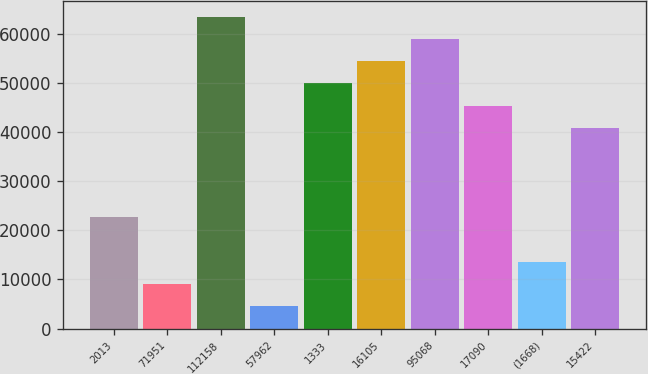Convert chart. <chart><loc_0><loc_0><loc_500><loc_500><bar_chart><fcel>2013<fcel>71951<fcel>112158<fcel>57962<fcel>1333<fcel>16105<fcel>95068<fcel>17090<fcel>(1668)<fcel>15422<nl><fcel>22713.5<fcel>9123.2<fcel>63484.4<fcel>4593.1<fcel>49894.1<fcel>54424.2<fcel>58954.3<fcel>45364<fcel>13653.3<fcel>40833.9<nl></chart> 